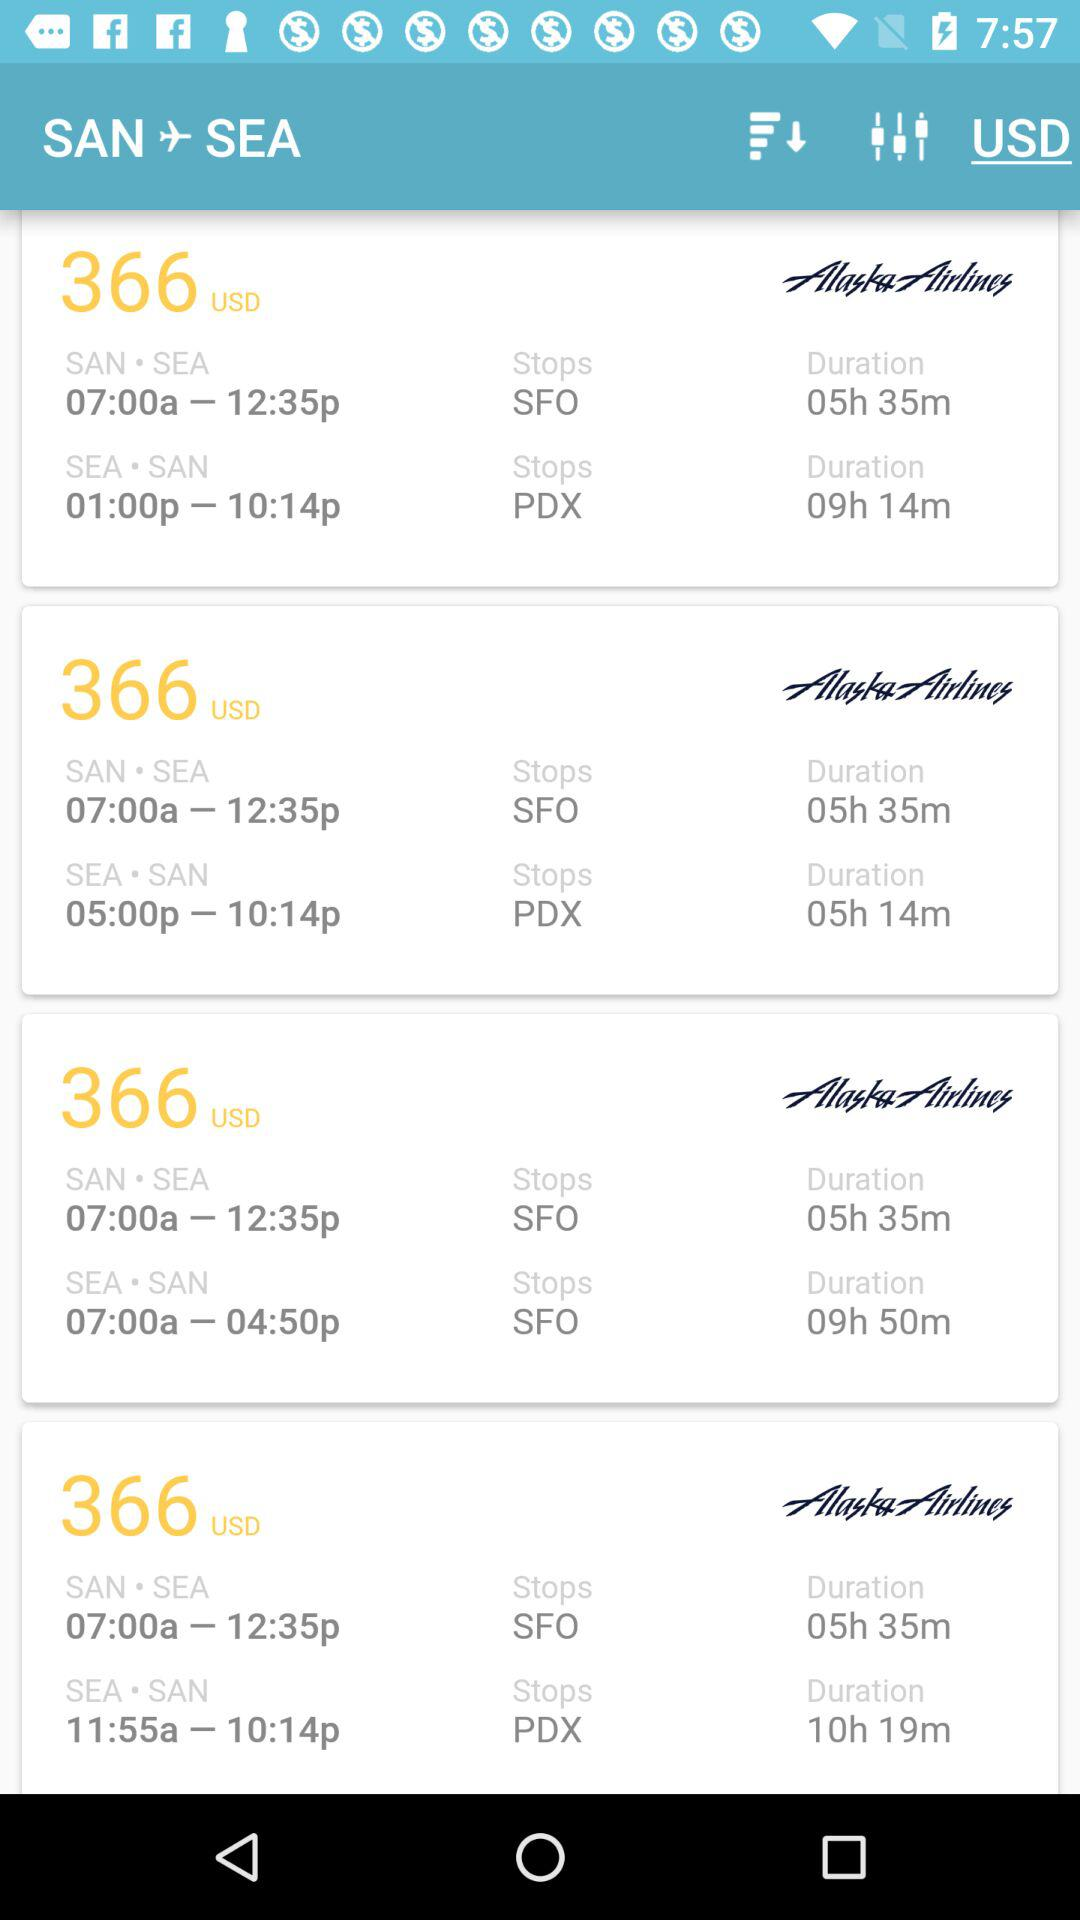How many flights are there from SAN to SEA?
Answer the question using a single word or phrase. 4 